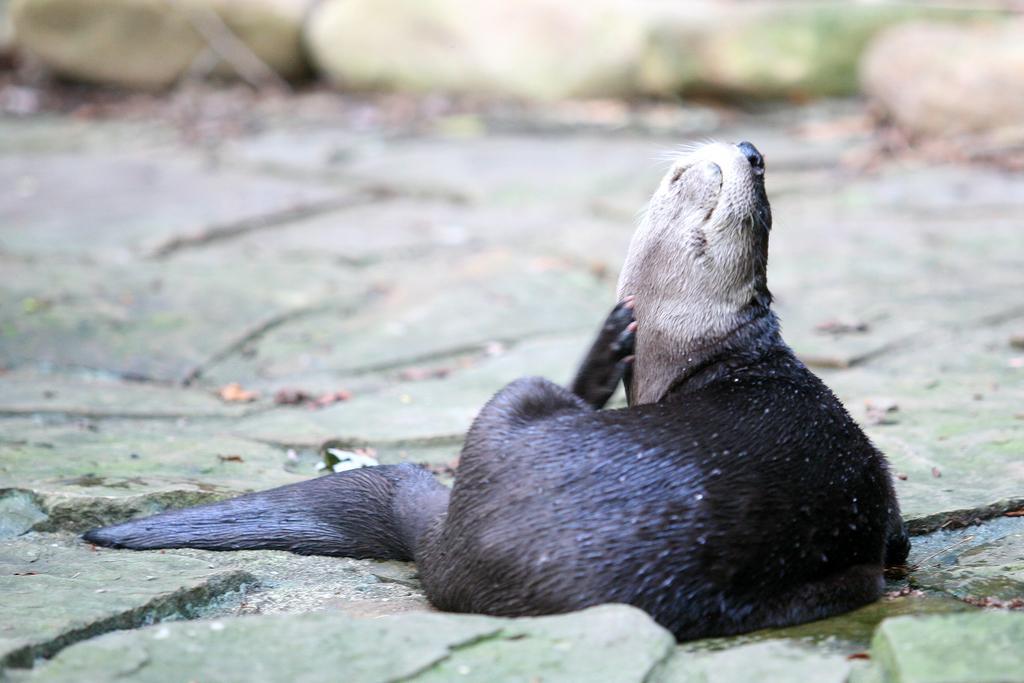Could you give a brief overview of what you see in this image? This picture contains a California sea lion, which is sitting on green color stones. In the background, it is blurred and this picture might be clicked in a zoo. 